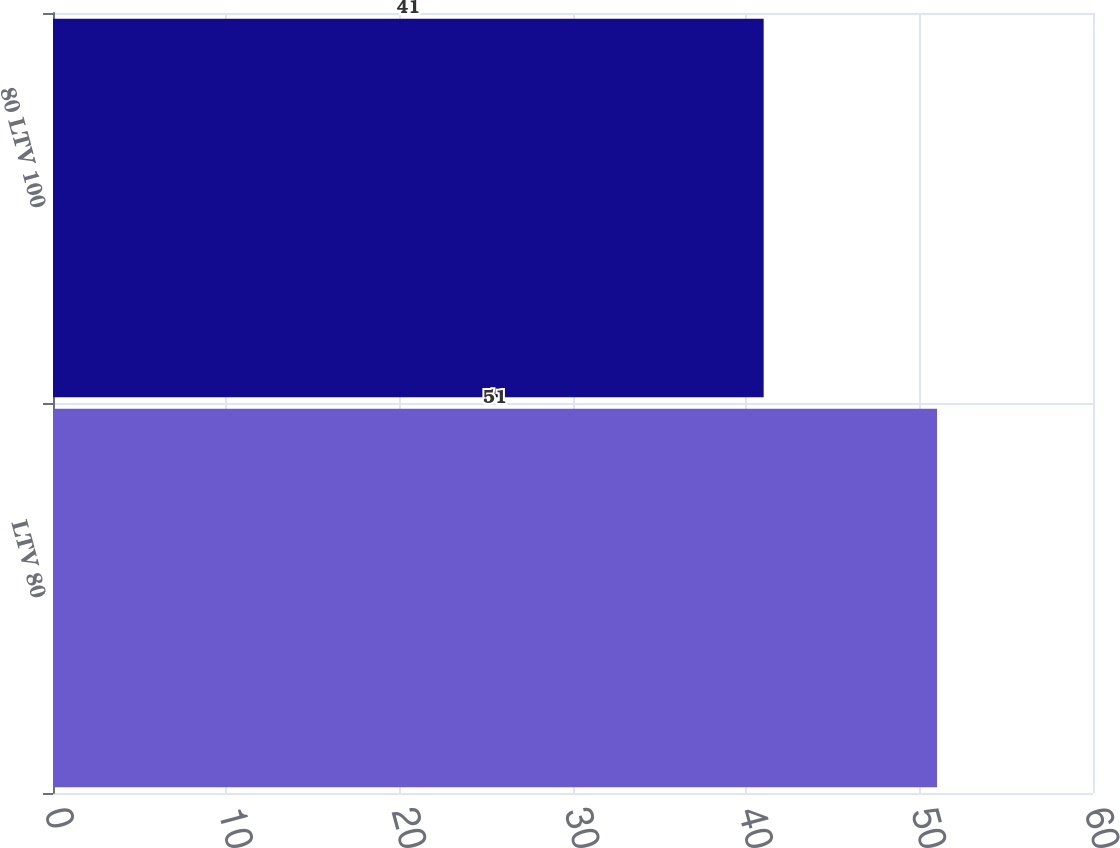Convert chart. <chart><loc_0><loc_0><loc_500><loc_500><bar_chart><fcel>LTV 80<fcel>80 LTV 100<nl><fcel>51<fcel>41<nl></chart> 